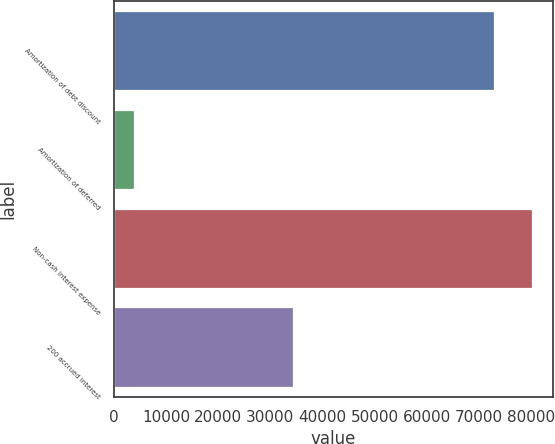Convert chart. <chart><loc_0><loc_0><loc_500><loc_500><bar_chart><fcel>Amortization of debt discount<fcel>Amortization of deferred<fcel>Non-cash interest expense<fcel>200 accrued interest<nl><fcel>72908<fcel>3906<fcel>80198.8<fcel>34427<nl></chart> 